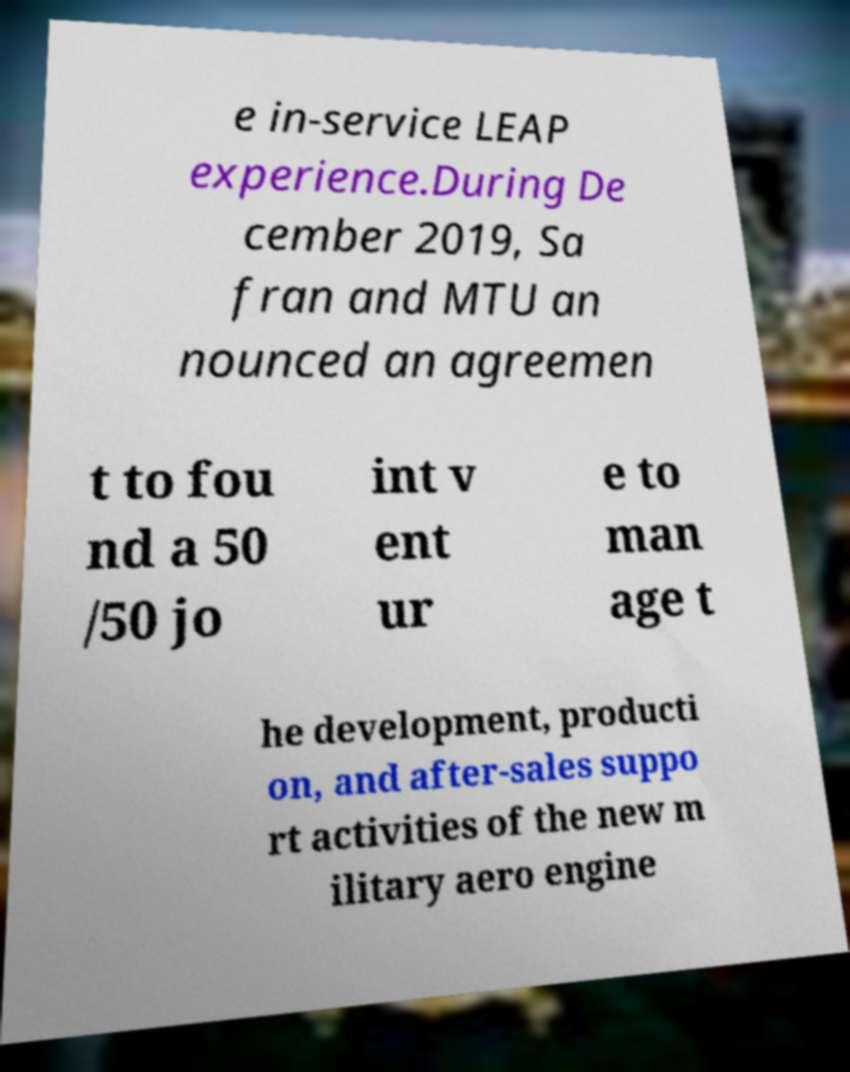I need the written content from this picture converted into text. Can you do that? e in-service LEAP experience.During De cember 2019, Sa fran and MTU an nounced an agreemen t to fou nd a 50 /50 jo int v ent ur e to man age t he development, producti on, and after-sales suppo rt activities of the new m ilitary aero engine 